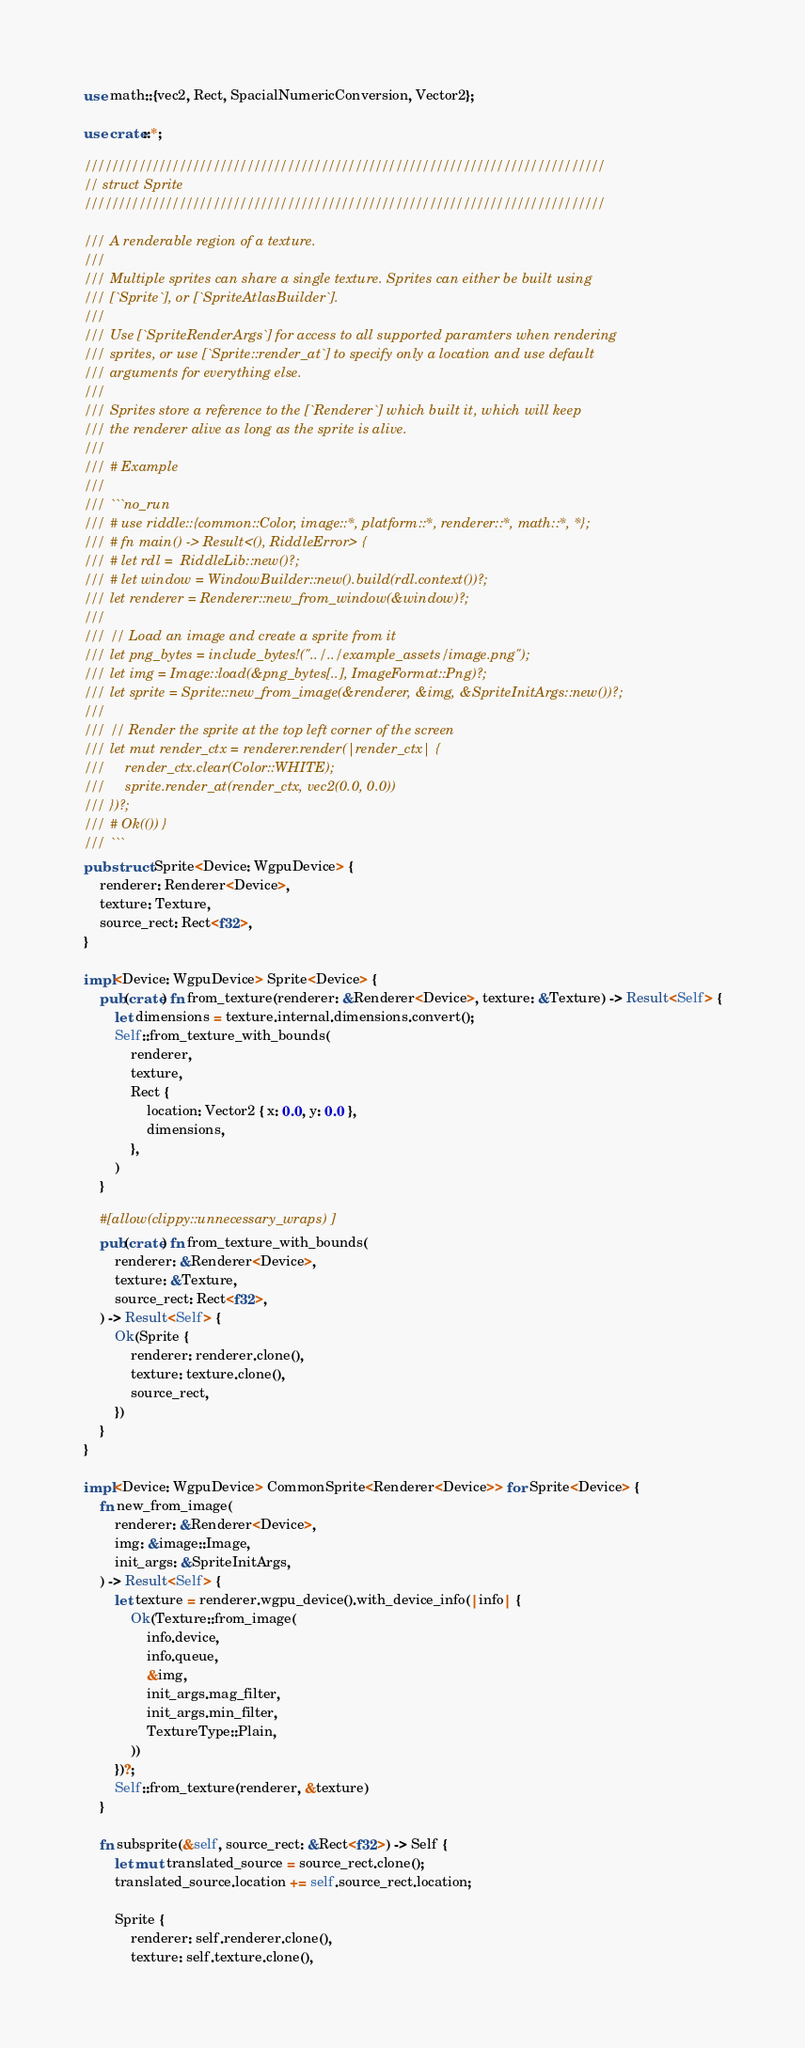<code> <loc_0><loc_0><loc_500><loc_500><_Rust_>use math::{vec2, Rect, SpacialNumericConversion, Vector2};

use crate::*;

/////////////////////////////////////////////////////////////////////////////
// struct Sprite
/////////////////////////////////////////////////////////////////////////////

/// A renderable region of a texture.
///
/// Multiple sprites can share a single texture. Sprites can either be built using
/// [`Sprite`], or [`SpriteAtlasBuilder`].
///
/// Use [`SpriteRenderArgs`] for access to all supported paramters when rendering
/// sprites, or use [`Sprite::render_at`] to specify only a location and use default
/// arguments for everything else.
///
/// Sprites store a reference to the [`Renderer`] which built it, which will keep
/// the renderer alive as long as the sprite is alive.
///
/// # Example
///
/// ```no_run
/// # use riddle::{common::Color, image::*, platform::*, renderer::*, math::*, *};
/// # fn main() -> Result<(), RiddleError> {
/// # let rdl =  RiddleLib::new()?;
/// # let window = WindowBuilder::new().build(rdl.context())?;
/// let renderer = Renderer::new_from_window(&window)?;
///
/// // Load an image and create a sprite from it
/// let png_bytes = include_bytes!("../../example_assets/image.png");
/// let img = Image::load(&png_bytes[..], ImageFormat::Png)?;
/// let sprite = Sprite::new_from_image(&renderer, &img, &SpriteInitArgs::new())?;
///
/// // Render the sprite at the top left corner of the screen
/// let mut render_ctx = renderer.render(|render_ctx| {
///     render_ctx.clear(Color::WHITE);
///     sprite.render_at(render_ctx, vec2(0.0, 0.0))
/// })?;
/// # Ok(()) }
/// ```
pub struct Sprite<Device: WgpuDevice> {
	renderer: Renderer<Device>,
	texture: Texture,
	source_rect: Rect<f32>,
}

impl<Device: WgpuDevice> Sprite<Device> {
	pub(crate) fn from_texture(renderer: &Renderer<Device>, texture: &Texture) -> Result<Self> {
		let dimensions = texture.internal.dimensions.convert();
		Self::from_texture_with_bounds(
			renderer,
			texture,
			Rect {
				location: Vector2 { x: 0.0, y: 0.0 },
				dimensions,
			},
		)
	}

	#[allow(clippy::unnecessary_wraps)]
	pub(crate) fn from_texture_with_bounds(
		renderer: &Renderer<Device>,
		texture: &Texture,
		source_rect: Rect<f32>,
	) -> Result<Self> {
		Ok(Sprite {
			renderer: renderer.clone(),
			texture: texture.clone(),
			source_rect,
		})
	}
}

impl<Device: WgpuDevice> CommonSprite<Renderer<Device>> for Sprite<Device> {
	fn new_from_image(
		renderer: &Renderer<Device>,
		img: &image::Image,
		init_args: &SpriteInitArgs,
	) -> Result<Self> {
		let texture = renderer.wgpu_device().with_device_info(|info| {
			Ok(Texture::from_image(
				info.device,
				info.queue,
				&img,
				init_args.mag_filter,
				init_args.min_filter,
				TextureType::Plain,
			))
		})?;
		Self::from_texture(renderer, &texture)
	}

	fn subsprite(&self, source_rect: &Rect<f32>) -> Self {
		let mut translated_source = source_rect.clone();
		translated_source.location += self.source_rect.location;

		Sprite {
			renderer: self.renderer.clone(),
			texture: self.texture.clone(),</code> 